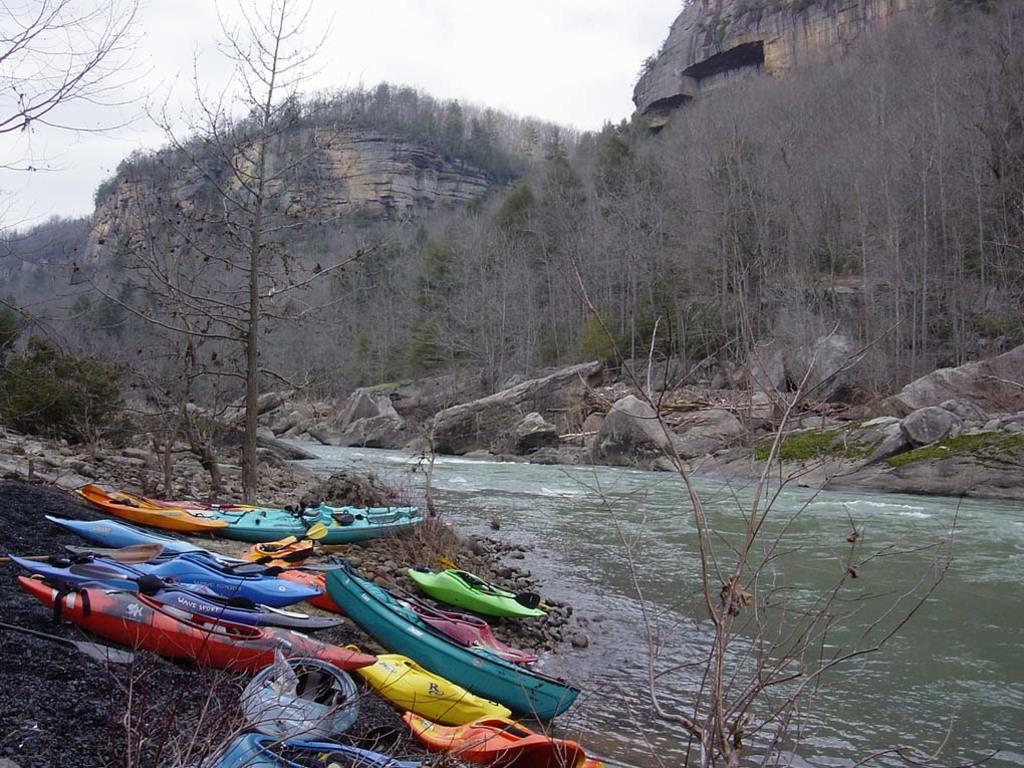What is the primary element visible in the image? There is water in the image. What objects are on the ground near the water? There are boats on the ground in the image. What type of vegetation can be seen in the image? There are trees in the image. What type of terrain is visible in the image? There are stones in the image. What can be seen in the distance in the image? There are mountains in the background of the image. What is visible above the mountains in the image? The sky is visible in the background of the image. Can you see the king's crown on the boats in the image? There is no crown visible on the boats in the image. How many fingers are visible on the trees in the image? Trees do not have fingers, so this question cannot be answered based on the image. 